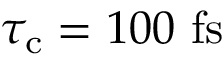Convert formula to latex. <formula><loc_0><loc_0><loc_500><loc_500>\tau _ { c } = 1 0 0 \ f s</formula> 